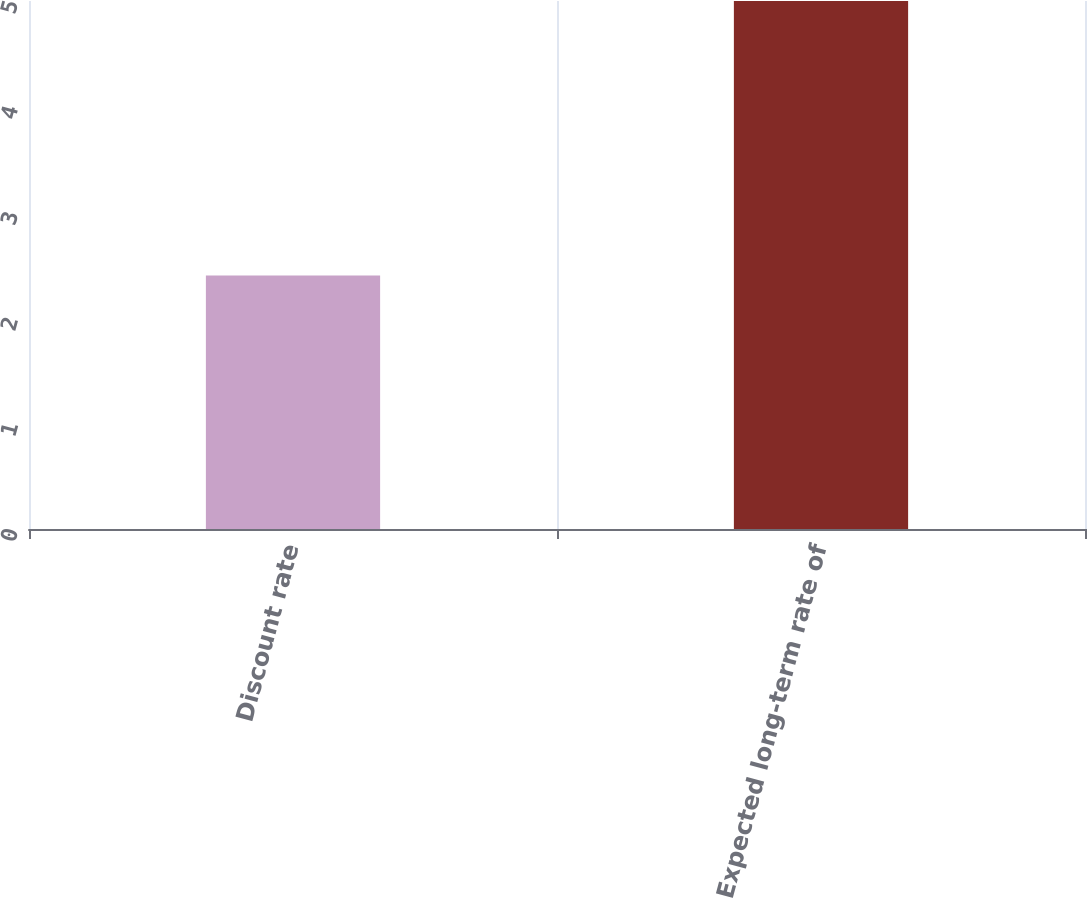Convert chart to OTSL. <chart><loc_0><loc_0><loc_500><loc_500><bar_chart><fcel>Discount rate<fcel>Expected long-term rate of<nl><fcel>2.4<fcel>5<nl></chart> 